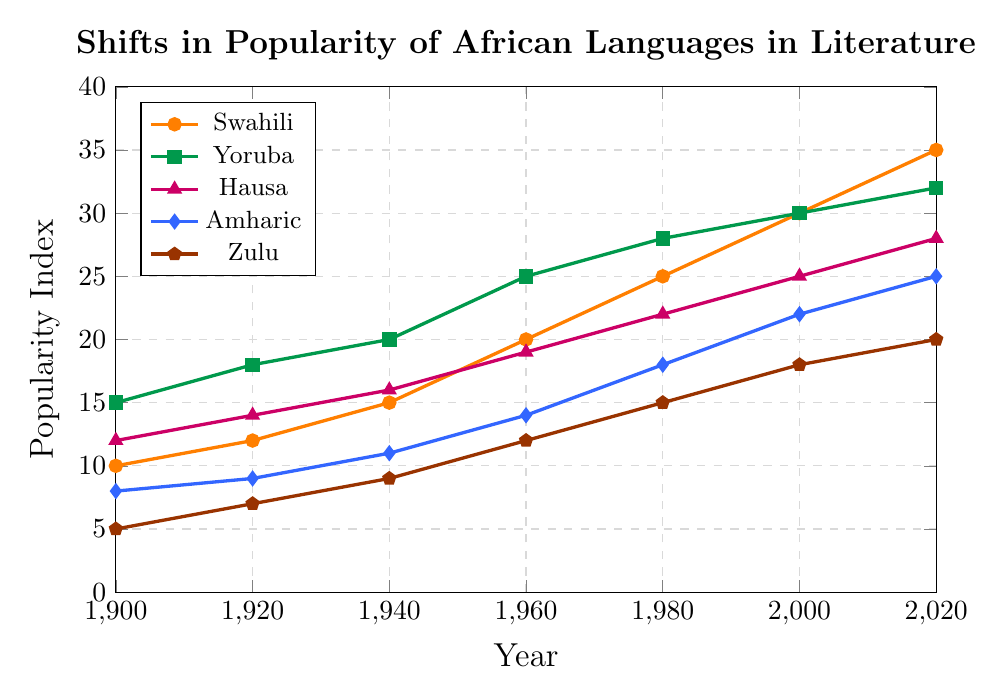Which language had the highest popularity index in 2020? Refer to the end points on the graph for 2020. Swahili has a popularity index of 35, higher than Yoruba's 32, Hausa's 28, Amharic's 25, and Zulu's 20
Answer: Swahili How did the popularity of Yoruba change from 1900 to 2000? Look at the indices for Yoruba in 1900 and 2000. It increased from 15 to 30, a change of 15 points
Answer: Increased by 15 points Between 1960 and 1980, which language saw the greatest increase in popularity? Compare the changes in indices for all languages between 1960 and 1980: Swahili (5), Yoruba (3), Hausa (3), Amharic (4), Zulu (3). Swahili had the highest increase
Answer: Swahili Which language had the smallest popularity index in 1940? Check the values for all languages in 1940: Swahili (15), Yoruba (20), Hausa (16), Amharic (11), Zulu (9). Zulu has the smallest index
Answer: Zulu What is the average popularity index of Amharic over the entire period? Sum the indices for Amharic (8 + 9 + 11 + 14 + 18 + 22 + 25 = 107) and divide by the number of data points (7): 107 / 7 = 15.29
Answer: 15.29 Compare the popularity index of Hausa and Zulu in 2000. In 2000, Hausa has an index of 25 and Zulu has an index of 18. Hausa's index is higher by 7 points
Answer: Hausa by 7 points What is the overall trend in the popularity of Swahili from 1900 to 2020? The indices for Swahili consistently increase from 10 in 1900 to 35 in 2020, indicating a steady rise
Answer: Steady rise Calculate the total increase in popularity for Zulu from 1900 to 2020. Subtract the index in 1900 (5) from the index in 2020 (20): 20 - 5 = 15
Answer: Increased by 15 points Which language had a popularity index closest to 20 in 1960? The indices in 1960 are: Swahili (20), Yoruba (25), Hausa (19), Amharic (14), Zulu (12). Swahili is exactly 20
Answer: Swahili How does the 2020 popularity index of Amharic compare to its 1900 index? Amharic's index in 2020 is 25, and in 1900 it was 8. The increase is 25 - 8 = 17
Answer: Increased by 17 points 